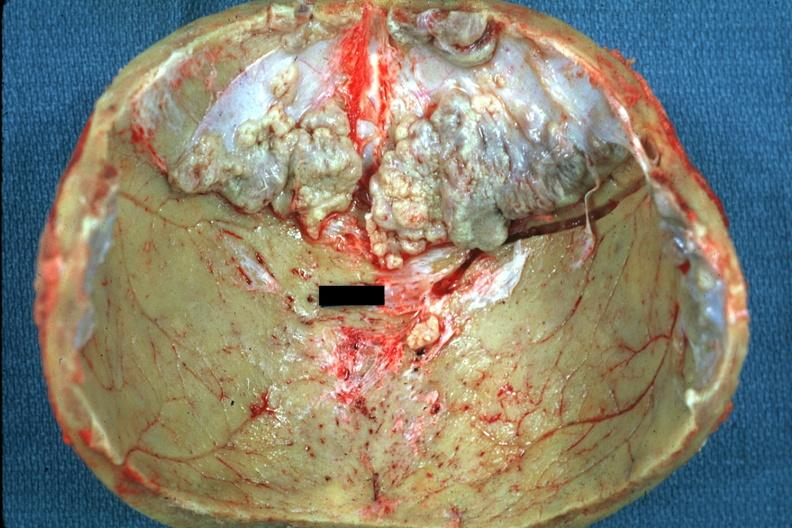what does this image show?
Answer the question using a single word or phrase. Several rather large lesions 